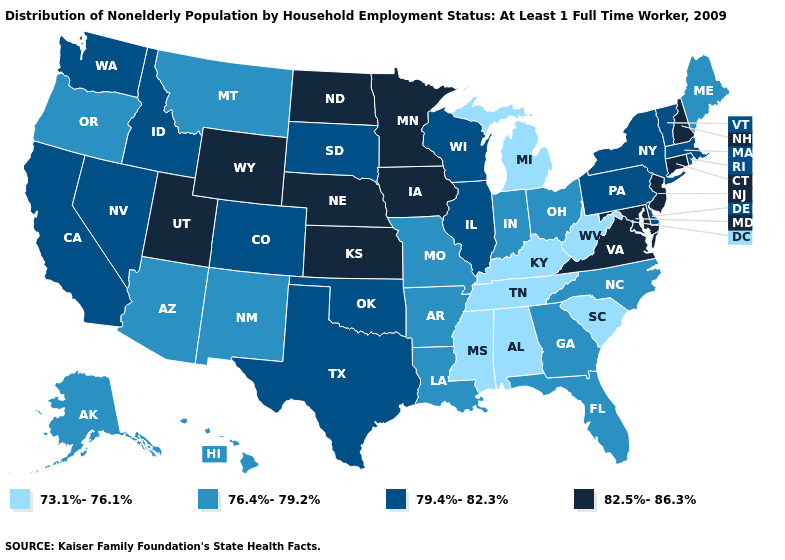Among the states that border Wyoming , which have the highest value?
Short answer required. Nebraska, Utah. Among the states that border Nevada , which have the highest value?
Quick response, please. Utah. Is the legend a continuous bar?
Give a very brief answer. No. What is the value of Maine?
Keep it brief. 76.4%-79.2%. Does Minnesota have a higher value than Tennessee?
Give a very brief answer. Yes. What is the value of Alabama?
Concise answer only. 73.1%-76.1%. Name the states that have a value in the range 82.5%-86.3%?
Short answer required. Connecticut, Iowa, Kansas, Maryland, Minnesota, Nebraska, New Hampshire, New Jersey, North Dakota, Utah, Virginia, Wyoming. What is the value of Ohio?
Quick response, please. 76.4%-79.2%. What is the value of Virginia?
Give a very brief answer. 82.5%-86.3%. Name the states that have a value in the range 73.1%-76.1%?
Keep it brief. Alabama, Kentucky, Michigan, Mississippi, South Carolina, Tennessee, West Virginia. What is the highest value in the USA?
Be succinct. 82.5%-86.3%. Name the states that have a value in the range 79.4%-82.3%?
Quick response, please. California, Colorado, Delaware, Idaho, Illinois, Massachusetts, Nevada, New York, Oklahoma, Pennsylvania, Rhode Island, South Dakota, Texas, Vermont, Washington, Wisconsin. How many symbols are there in the legend?
Short answer required. 4. Which states have the highest value in the USA?
Be succinct. Connecticut, Iowa, Kansas, Maryland, Minnesota, Nebraska, New Hampshire, New Jersey, North Dakota, Utah, Virginia, Wyoming. Which states have the lowest value in the USA?
Be succinct. Alabama, Kentucky, Michigan, Mississippi, South Carolina, Tennessee, West Virginia. 